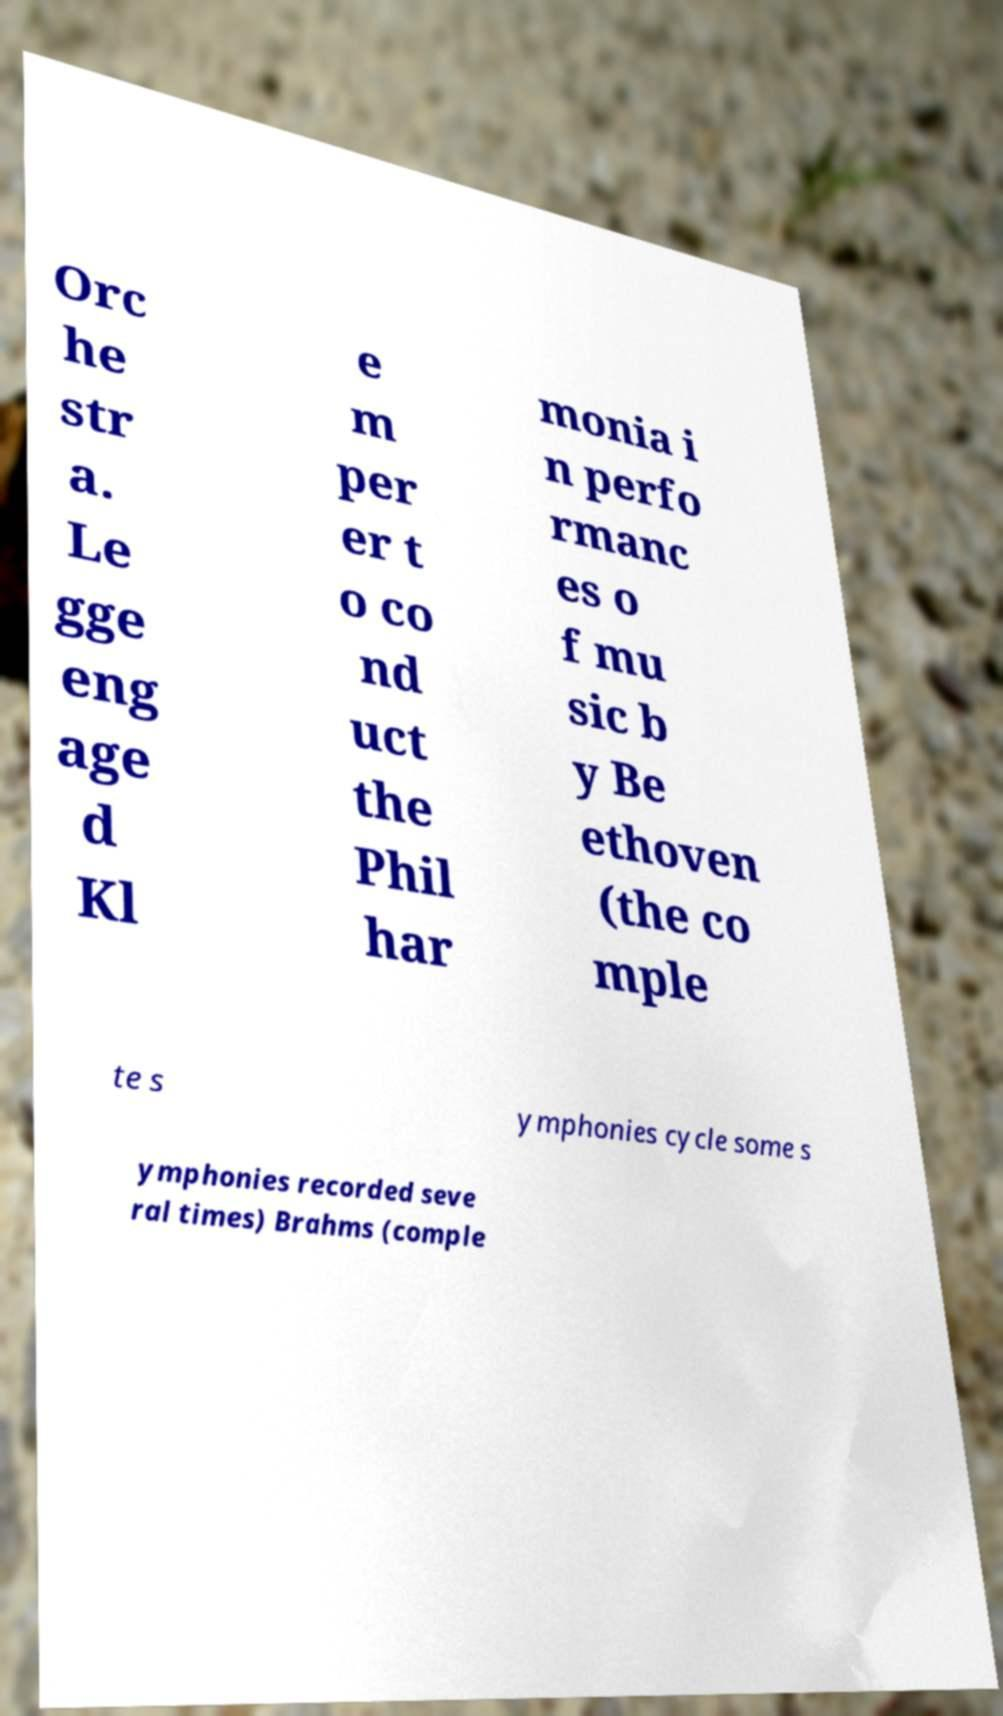I need the written content from this picture converted into text. Can you do that? Orc he str a. Le gge eng age d Kl e m per er t o co nd uct the Phil har monia i n perfo rmanc es o f mu sic b y Be ethoven (the co mple te s ymphonies cycle some s ymphonies recorded seve ral times) Brahms (comple 